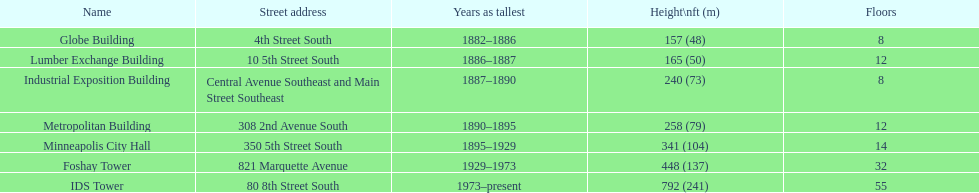Which edifice has 8 storeys and is 240 ft in height? Industrial Exposition Building. 